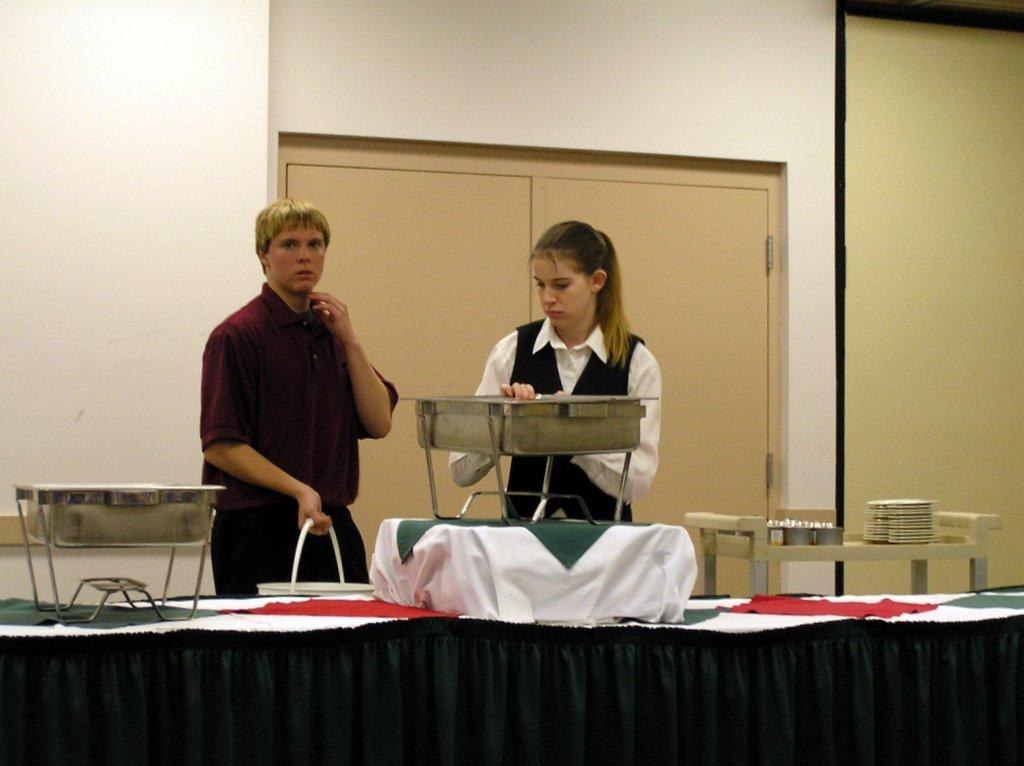How many people are present in the image? There are two people standing in the image. What are the people holding in the image? The people are holding something, but the specific object cannot be determined from the provided facts. What can be seen on the table in the image? There are vessels on a table in the image. What colors can be seen in the background of the image? There is a cream-colored door and a white wall visible in the background. Can you tell me how many times the person on the left sneezes in the image? There is no indication of anyone sneezing in the image, so it cannot be determined from the provided facts. 